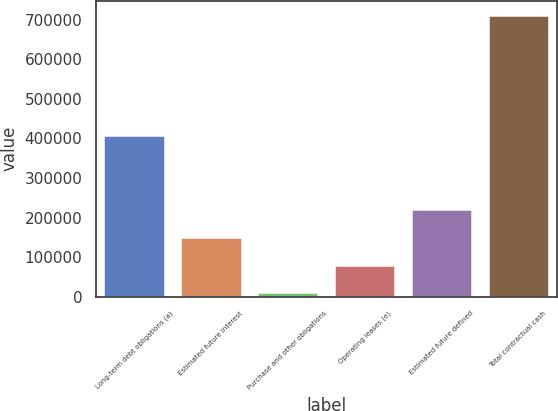Convert chart. <chart><loc_0><loc_0><loc_500><loc_500><bar_chart><fcel>Long-term debt obligations (a)<fcel>Estimated future interest<fcel>Purchase and other obligations<fcel>Operating leases (e)<fcel>Estimated future defined<fcel>Total contractual cash<nl><fcel>409295<fcel>151508<fcel>11350<fcel>81429<fcel>221587<fcel>712140<nl></chart> 